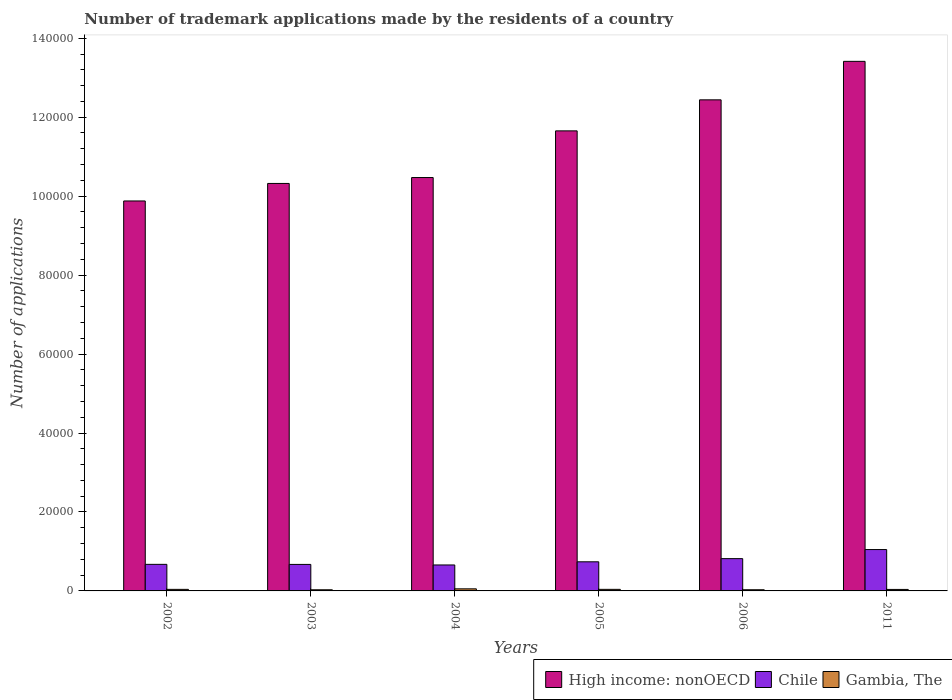How many different coloured bars are there?
Provide a succinct answer. 3. How many groups of bars are there?
Your response must be concise. 6. How many bars are there on the 6th tick from the left?
Ensure brevity in your answer.  3. What is the label of the 4th group of bars from the left?
Ensure brevity in your answer.  2005. What is the number of trademark applications made by the residents in Chile in 2003?
Your response must be concise. 6716. Across all years, what is the maximum number of trademark applications made by the residents in Chile?
Provide a short and direct response. 1.05e+04. Across all years, what is the minimum number of trademark applications made by the residents in Chile?
Your answer should be very brief. 6576. In which year was the number of trademark applications made by the residents in High income: nonOECD maximum?
Give a very brief answer. 2011. In which year was the number of trademark applications made by the residents in High income: nonOECD minimum?
Your answer should be very brief. 2002. What is the total number of trademark applications made by the residents in Chile in the graph?
Offer a terse response. 4.61e+04. What is the difference between the number of trademark applications made by the residents in Gambia, The in 2003 and that in 2004?
Ensure brevity in your answer.  -239. What is the difference between the number of trademark applications made by the residents in Gambia, The in 2011 and the number of trademark applications made by the residents in Chile in 2002?
Give a very brief answer. -6353. What is the average number of trademark applications made by the residents in Gambia, The per year?
Offer a terse response. 381.5. In the year 2011, what is the difference between the number of trademark applications made by the residents in Gambia, The and number of trademark applications made by the residents in Chile?
Give a very brief answer. -1.01e+04. What is the ratio of the number of trademark applications made by the residents in High income: nonOECD in 2002 to that in 2003?
Give a very brief answer. 0.96. What is the difference between the highest and the second highest number of trademark applications made by the residents in Chile?
Make the answer very short. 2302. What is the difference between the highest and the lowest number of trademark applications made by the residents in High income: nonOECD?
Offer a terse response. 3.54e+04. What does the 3rd bar from the left in 2006 represents?
Provide a succinct answer. Gambia, The. Is it the case that in every year, the sum of the number of trademark applications made by the residents in Gambia, The and number of trademark applications made by the residents in Chile is greater than the number of trademark applications made by the residents in High income: nonOECD?
Your response must be concise. No. Are all the bars in the graph horizontal?
Offer a very short reply. No. Are the values on the major ticks of Y-axis written in scientific E-notation?
Give a very brief answer. No. Does the graph contain any zero values?
Offer a terse response. No. Where does the legend appear in the graph?
Your response must be concise. Bottom right. How many legend labels are there?
Offer a terse response. 3. How are the legend labels stacked?
Give a very brief answer. Horizontal. What is the title of the graph?
Offer a very short reply. Number of trademark applications made by the residents of a country. What is the label or title of the X-axis?
Your response must be concise. Years. What is the label or title of the Y-axis?
Make the answer very short. Number of applications. What is the Number of applications of High income: nonOECD in 2002?
Your answer should be compact. 9.88e+04. What is the Number of applications of Chile in 2002?
Provide a short and direct response. 6730. What is the Number of applications of Gambia, The in 2002?
Ensure brevity in your answer.  395. What is the Number of applications of High income: nonOECD in 2003?
Your response must be concise. 1.03e+05. What is the Number of applications of Chile in 2003?
Keep it short and to the point. 6716. What is the Number of applications of Gambia, The in 2003?
Ensure brevity in your answer.  291. What is the Number of applications of High income: nonOECD in 2004?
Provide a succinct answer. 1.05e+05. What is the Number of applications in Chile in 2004?
Provide a short and direct response. 6576. What is the Number of applications in Gambia, The in 2004?
Offer a terse response. 530. What is the Number of applications in High income: nonOECD in 2005?
Your response must be concise. 1.17e+05. What is the Number of applications in Chile in 2005?
Provide a succinct answer. 7374. What is the Number of applications in Gambia, The in 2005?
Your response must be concise. 399. What is the Number of applications of High income: nonOECD in 2006?
Provide a succinct answer. 1.24e+05. What is the Number of applications of Chile in 2006?
Your answer should be compact. 8177. What is the Number of applications in Gambia, The in 2006?
Offer a very short reply. 297. What is the Number of applications in High income: nonOECD in 2011?
Give a very brief answer. 1.34e+05. What is the Number of applications in Chile in 2011?
Keep it short and to the point. 1.05e+04. What is the Number of applications in Gambia, The in 2011?
Your answer should be compact. 377. Across all years, what is the maximum Number of applications of High income: nonOECD?
Offer a very short reply. 1.34e+05. Across all years, what is the maximum Number of applications in Chile?
Ensure brevity in your answer.  1.05e+04. Across all years, what is the maximum Number of applications of Gambia, The?
Make the answer very short. 530. Across all years, what is the minimum Number of applications in High income: nonOECD?
Provide a succinct answer. 9.88e+04. Across all years, what is the minimum Number of applications in Chile?
Your answer should be very brief. 6576. Across all years, what is the minimum Number of applications in Gambia, The?
Your response must be concise. 291. What is the total Number of applications in High income: nonOECD in the graph?
Offer a very short reply. 6.82e+05. What is the total Number of applications of Chile in the graph?
Your answer should be very brief. 4.61e+04. What is the total Number of applications of Gambia, The in the graph?
Make the answer very short. 2289. What is the difference between the Number of applications of High income: nonOECD in 2002 and that in 2003?
Offer a very short reply. -4438. What is the difference between the Number of applications in Chile in 2002 and that in 2003?
Make the answer very short. 14. What is the difference between the Number of applications in Gambia, The in 2002 and that in 2003?
Give a very brief answer. 104. What is the difference between the Number of applications in High income: nonOECD in 2002 and that in 2004?
Your answer should be very brief. -5933. What is the difference between the Number of applications in Chile in 2002 and that in 2004?
Provide a succinct answer. 154. What is the difference between the Number of applications of Gambia, The in 2002 and that in 2004?
Offer a terse response. -135. What is the difference between the Number of applications in High income: nonOECD in 2002 and that in 2005?
Give a very brief answer. -1.78e+04. What is the difference between the Number of applications in Chile in 2002 and that in 2005?
Offer a terse response. -644. What is the difference between the Number of applications in Gambia, The in 2002 and that in 2005?
Offer a terse response. -4. What is the difference between the Number of applications in High income: nonOECD in 2002 and that in 2006?
Your answer should be very brief. -2.56e+04. What is the difference between the Number of applications in Chile in 2002 and that in 2006?
Make the answer very short. -1447. What is the difference between the Number of applications in High income: nonOECD in 2002 and that in 2011?
Your answer should be very brief. -3.54e+04. What is the difference between the Number of applications of Chile in 2002 and that in 2011?
Make the answer very short. -3749. What is the difference between the Number of applications in Gambia, The in 2002 and that in 2011?
Your response must be concise. 18. What is the difference between the Number of applications of High income: nonOECD in 2003 and that in 2004?
Make the answer very short. -1495. What is the difference between the Number of applications in Chile in 2003 and that in 2004?
Offer a very short reply. 140. What is the difference between the Number of applications of Gambia, The in 2003 and that in 2004?
Your answer should be very brief. -239. What is the difference between the Number of applications of High income: nonOECD in 2003 and that in 2005?
Your answer should be very brief. -1.33e+04. What is the difference between the Number of applications of Chile in 2003 and that in 2005?
Provide a succinct answer. -658. What is the difference between the Number of applications of Gambia, The in 2003 and that in 2005?
Offer a terse response. -108. What is the difference between the Number of applications of High income: nonOECD in 2003 and that in 2006?
Give a very brief answer. -2.12e+04. What is the difference between the Number of applications in Chile in 2003 and that in 2006?
Offer a very short reply. -1461. What is the difference between the Number of applications in Gambia, The in 2003 and that in 2006?
Keep it short and to the point. -6. What is the difference between the Number of applications in High income: nonOECD in 2003 and that in 2011?
Keep it short and to the point. -3.09e+04. What is the difference between the Number of applications in Chile in 2003 and that in 2011?
Offer a terse response. -3763. What is the difference between the Number of applications in Gambia, The in 2003 and that in 2011?
Provide a short and direct response. -86. What is the difference between the Number of applications of High income: nonOECD in 2004 and that in 2005?
Keep it short and to the point. -1.18e+04. What is the difference between the Number of applications of Chile in 2004 and that in 2005?
Provide a succinct answer. -798. What is the difference between the Number of applications of Gambia, The in 2004 and that in 2005?
Your answer should be compact. 131. What is the difference between the Number of applications in High income: nonOECD in 2004 and that in 2006?
Make the answer very short. -1.97e+04. What is the difference between the Number of applications in Chile in 2004 and that in 2006?
Your answer should be compact. -1601. What is the difference between the Number of applications of Gambia, The in 2004 and that in 2006?
Offer a terse response. 233. What is the difference between the Number of applications in High income: nonOECD in 2004 and that in 2011?
Keep it short and to the point. -2.94e+04. What is the difference between the Number of applications in Chile in 2004 and that in 2011?
Offer a terse response. -3903. What is the difference between the Number of applications of Gambia, The in 2004 and that in 2011?
Make the answer very short. 153. What is the difference between the Number of applications of High income: nonOECD in 2005 and that in 2006?
Your answer should be compact. -7862. What is the difference between the Number of applications in Chile in 2005 and that in 2006?
Offer a terse response. -803. What is the difference between the Number of applications of Gambia, The in 2005 and that in 2006?
Make the answer very short. 102. What is the difference between the Number of applications of High income: nonOECD in 2005 and that in 2011?
Offer a terse response. -1.76e+04. What is the difference between the Number of applications in Chile in 2005 and that in 2011?
Provide a short and direct response. -3105. What is the difference between the Number of applications of Gambia, The in 2005 and that in 2011?
Ensure brevity in your answer.  22. What is the difference between the Number of applications of High income: nonOECD in 2006 and that in 2011?
Give a very brief answer. -9748. What is the difference between the Number of applications of Chile in 2006 and that in 2011?
Give a very brief answer. -2302. What is the difference between the Number of applications of Gambia, The in 2006 and that in 2011?
Make the answer very short. -80. What is the difference between the Number of applications of High income: nonOECD in 2002 and the Number of applications of Chile in 2003?
Offer a very short reply. 9.21e+04. What is the difference between the Number of applications of High income: nonOECD in 2002 and the Number of applications of Gambia, The in 2003?
Keep it short and to the point. 9.85e+04. What is the difference between the Number of applications of Chile in 2002 and the Number of applications of Gambia, The in 2003?
Provide a short and direct response. 6439. What is the difference between the Number of applications of High income: nonOECD in 2002 and the Number of applications of Chile in 2004?
Ensure brevity in your answer.  9.22e+04. What is the difference between the Number of applications of High income: nonOECD in 2002 and the Number of applications of Gambia, The in 2004?
Offer a very short reply. 9.82e+04. What is the difference between the Number of applications in Chile in 2002 and the Number of applications in Gambia, The in 2004?
Keep it short and to the point. 6200. What is the difference between the Number of applications in High income: nonOECD in 2002 and the Number of applications in Chile in 2005?
Give a very brief answer. 9.14e+04. What is the difference between the Number of applications of High income: nonOECD in 2002 and the Number of applications of Gambia, The in 2005?
Provide a succinct answer. 9.84e+04. What is the difference between the Number of applications in Chile in 2002 and the Number of applications in Gambia, The in 2005?
Offer a very short reply. 6331. What is the difference between the Number of applications of High income: nonOECD in 2002 and the Number of applications of Chile in 2006?
Provide a short and direct response. 9.06e+04. What is the difference between the Number of applications of High income: nonOECD in 2002 and the Number of applications of Gambia, The in 2006?
Your answer should be very brief. 9.85e+04. What is the difference between the Number of applications in Chile in 2002 and the Number of applications in Gambia, The in 2006?
Offer a very short reply. 6433. What is the difference between the Number of applications in High income: nonOECD in 2002 and the Number of applications in Chile in 2011?
Ensure brevity in your answer.  8.83e+04. What is the difference between the Number of applications in High income: nonOECD in 2002 and the Number of applications in Gambia, The in 2011?
Your response must be concise. 9.84e+04. What is the difference between the Number of applications in Chile in 2002 and the Number of applications in Gambia, The in 2011?
Ensure brevity in your answer.  6353. What is the difference between the Number of applications of High income: nonOECD in 2003 and the Number of applications of Chile in 2004?
Offer a very short reply. 9.66e+04. What is the difference between the Number of applications in High income: nonOECD in 2003 and the Number of applications in Gambia, The in 2004?
Offer a terse response. 1.03e+05. What is the difference between the Number of applications in Chile in 2003 and the Number of applications in Gambia, The in 2004?
Offer a very short reply. 6186. What is the difference between the Number of applications of High income: nonOECD in 2003 and the Number of applications of Chile in 2005?
Your answer should be compact. 9.58e+04. What is the difference between the Number of applications of High income: nonOECD in 2003 and the Number of applications of Gambia, The in 2005?
Offer a terse response. 1.03e+05. What is the difference between the Number of applications of Chile in 2003 and the Number of applications of Gambia, The in 2005?
Offer a terse response. 6317. What is the difference between the Number of applications of High income: nonOECD in 2003 and the Number of applications of Chile in 2006?
Make the answer very short. 9.50e+04. What is the difference between the Number of applications in High income: nonOECD in 2003 and the Number of applications in Gambia, The in 2006?
Give a very brief answer. 1.03e+05. What is the difference between the Number of applications in Chile in 2003 and the Number of applications in Gambia, The in 2006?
Your response must be concise. 6419. What is the difference between the Number of applications of High income: nonOECD in 2003 and the Number of applications of Chile in 2011?
Ensure brevity in your answer.  9.27e+04. What is the difference between the Number of applications in High income: nonOECD in 2003 and the Number of applications in Gambia, The in 2011?
Your answer should be very brief. 1.03e+05. What is the difference between the Number of applications of Chile in 2003 and the Number of applications of Gambia, The in 2011?
Ensure brevity in your answer.  6339. What is the difference between the Number of applications in High income: nonOECD in 2004 and the Number of applications in Chile in 2005?
Make the answer very short. 9.73e+04. What is the difference between the Number of applications in High income: nonOECD in 2004 and the Number of applications in Gambia, The in 2005?
Offer a terse response. 1.04e+05. What is the difference between the Number of applications in Chile in 2004 and the Number of applications in Gambia, The in 2005?
Your answer should be very brief. 6177. What is the difference between the Number of applications in High income: nonOECD in 2004 and the Number of applications in Chile in 2006?
Your answer should be very brief. 9.65e+04. What is the difference between the Number of applications of High income: nonOECD in 2004 and the Number of applications of Gambia, The in 2006?
Ensure brevity in your answer.  1.04e+05. What is the difference between the Number of applications of Chile in 2004 and the Number of applications of Gambia, The in 2006?
Keep it short and to the point. 6279. What is the difference between the Number of applications in High income: nonOECD in 2004 and the Number of applications in Chile in 2011?
Your answer should be compact. 9.42e+04. What is the difference between the Number of applications of High income: nonOECD in 2004 and the Number of applications of Gambia, The in 2011?
Provide a succinct answer. 1.04e+05. What is the difference between the Number of applications of Chile in 2004 and the Number of applications of Gambia, The in 2011?
Keep it short and to the point. 6199. What is the difference between the Number of applications of High income: nonOECD in 2005 and the Number of applications of Chile in 2006?
Keep it short and to the point. 1.08e+05. What is the difference between the Number of applications of High income: nonOECD in 2005 and the Number of applications of Gambia, The in 2006?
Your answer should be compact. 1.16e+05. What is the difference between the Number of applications of Chile in 2005 and the Number of applications of Gambia, The in 2006?
Give a very brief answer. 7077. What is the difference between the Number of applications of High income: nonOECD in 2005 and the Number of applications of Chile in 2011?
Give a very brief answer. 1.06e+05. What is the difference between the Number of applications of High income: nonOECD in 2005 and the Number of applications of Gambia, The in 2011?
Keep it short and to the point. 1.16e+05. What is the difference between the Number of applications in Chile in 2005 and the Number of applications in Gambia, The in 2011?
Provide a succinct answer. 6997. What is the difference between the Number of applications of High income: nonOECD in 2006 and the Number of applications of Chile in 2011?
Your answer should be compact. 1.14e+05. What is the difference between the Number of applications of High income: nonOECD in 2006 and the Number of applications of Gambia, The in 2011?
Your answer should be compact. 1.24e+05. What is the difference between the Number of applications in Chile in 2006 and the Number of applications in Gambia, The in 2011?
Provide a succinct answer. 7800. What is the average Number of applications in High income: nonOECD per year?
Your answer should be compact. 1.14e+05. What is the average Number of applications of Chile per year?
Offer a very short reply. 7675.33. What is the average Number of applications in Gambia, The per year?
Provide a short and direct response. 381.5. In the year 2002, what is the difference between the Number of applications of High income: nonOECD and Number of applications of Chile?
Give a very brief answer. 9.20e+04. In the year 2002, what is the difference between the Number of applications in High income: nonOECD and Number of applications in Gambia, The?
Keep it short and to the point. 9.84e+04. In the year 2002, what is the difference between the Number of applications of Chile and Number of applications of Gambia, The?
Ensure brevity in your answer.  6335. In the year 2003, what is the difference between the Number of applications in High income: nonOECD and Number of applications in Chile?
Make the answer very short. 9.65e+04. In the year 2003, what is the difference between the Number of applications in High income: nonOECD and Number of applications in Gambia, The?
Make the answer very short. 1.03e+05. In the year 2003, what is the difference between the Number of applications in Chile and Number of applications in Gambia, The?
Keep it short and to the point. 6425. In the year 2004, what is the difference between the Number of applications in High income: nonOECD and Number of applications in Chile?
Ensure brevity in your answer.  9.81e+04. In the year 2004, what is the difference between the Number of applications in High income: nonOECD and Number of applications in Gambia, The?
Your response must be concise. 1.04e+05. In the year 2004, what is the difference between the Number of applications of Chile and Number of applications of Gambia, The?
Keep it short and to the point. 6046. In the year 2005, what is the difference between the Number of applications in High income: nonOECD and Number of applications in Chile?
Provide a short and direct response. 1.09e+05. In the year 2005, what is the difference between the Number of applications of High income: nonOECD and Number of applications of Gambia, The?
Your response must be concise. 1.16e+05. In the year 2005, what is the difference between the Number of applications of Chile and Number of applications of Gambia, The?
Keep it short and to the point. 6975. In the year 2006, what is the difference between the Number of applications in High income: nonOECD and Number of applications in Chile?
Your answer should be very brief. 1.16e+05. In the year 2006, what is the difference between the Number of applications in High income: nonOECD and Number of applications in Gambia, The?
Provide a succinct answer. 1.24e+05. In the year 2006, what is the difference between the Number of applications of Chile and Number of applications of Gambia, The?
Keep it short and to the point. 7880. In the year 2011, what is the difference between the Number of applications of High income: nonOECD and Number of applications of Chile?
Your answer should be very brief. 1.24e+05. In the year 2011, what is the difference between the Number of applications in High income: nonOECD and Number of applications in Gambia, The?
Your answer should be very brief. 1.34e+05. In the year 2011, what is the difference between the Number of applications in Chile and Number of applications in Gambia, The?
Ensure brevity in your answer.  1.01e+04. What is the ratio of the Number of applications of Chile in 2002 to that in 2003?
Give a very brief answer. 1. What is the ratio of the Number of applications in Gambia, The in 2002 to that in 2003?
Keep it short and to the point. 1.36. What is the ratio of the Number of applications of High income: nonOECD in 2002 to that in 2004?
Ensure brevity in your answer.  0.94. What is the ratio of the Number of applications of Chile in 2002 to that in 2004?
Give a very brief answer. 1.02. What is the ratio of the Number of applications in Gambia, The in 2002 to that in 2004?
Give a very brief answer. 0.75. What is the ratio of the Number of applications in High income: nonOECD in 2002 to that in 2005?
Give a very brief answer. 0.85. What is the ratio of the Number of applications in Chile in 2002 to that in 2005?
Provide a succinct answer. 0.91. What is the ratio of the Number of applications of Gambia, The in 2002 to that in 2005?
Make the answer very short. 0.99. What is the ratio of the Number of applications of High income: nonOECD in 2002 to that in 2006?
Make the answer very short. 0.79. What is the ratio of the Number of applications of Chile in 2002 to that in 2006?
Provide a succinct answer. 0.82. What is the ratio of the Number of applications of Gambia, The in 2002 to that in 2006?
Your response must be concise. 1.33. What is the ratio of the Number of applications of High income: nonOECD in 2002 to that in 2011?
Offer a very short reply. 0.74. What is the ratio of the Number of applications of Chile in 2002 to that in 2011?
Make the answer very short. 0.64. What is the ratio of the Number of applications of Gambia, The in 2002 to that in 2011?
Make the answer very short. 1.05. What is the ratio of the Number of applications of High income: nonOECD in 2003 to that in 2004?
Your response must be concise. 0.99. What is the ratio of the Number of applications in Chile in 2003 to that in 2004?
Ensure brevity in your answer.  1.02. What is the ratio of the Number of applications in Gambia, The in 2003 to that in 2004?
Your answer should be very brief. 0.55. What is the ratio of the Number of applications in High income: nonOECD in 2003 to that in 2005?
Your answer should be very brief. 0.89. What is the ratio of the Number of applications of Chile in 2003 to that in 2005?
Offer a very short reply. 0.91. What is the ratio of the Number of applications of Gambia, The in 2003 to that in 2005?
Provide a short and direct response. 0.73. What is the ratio of the Number of applications in High income: nonOECD in 2003 to that in 2006?
Ensure brevity in your answer.  0.83. What is the ratio of the Number of applications of Chile in 2003 to that in 2006?
Offer a terse response. 0.82. What is the ratio of the Number of applications of Gambia, The in 2003 to that in 2006?
Provide a succinct answer. 0.98. What is the ratio of the Number of applications of High income: nonOECD in 2003 to that in 2011?
Your answer should be very brief. 0.77. What is the ratio of the Number of applications of Chile in 2003 to that in 2011?
Give a very brief answer. 0.64. What is the ratio of the Number of applications in Gambia, The in 2003 to that in 2011?
Keep it short and to the point. 0.77. What is the ratio of the Number of applications of High income: nonOECD in 2004 to that in 2005?
Make the answer very short. 0.9. What is the ratio of the Number of applications of Chile in 2004 to that in 2005?
Offer a terse response. 0.89. What is the ratio of the Number of applications in Gambia, The in 2004 to that in 2005?
Offer a terse response. 1.33. What is the ratio of the Number of applications in High income: nonOECD in 2004 to that in 2006?
Your response must be concise. 0.84. What is the ratio of the Number of applications in Chile in 2004 to that in 2006?
Your response must be concise. 0.8. What is the ratio of the Number of applications of Gambia, The in 2004 to that in 2006?
Keep it short and to the point. 1.78. What is the ratio of the Number of applications in High income: nonOECD in 2004 to that in 2011?
Your answer should be very brief. 0.78. What is the ratio of the Number of applications in Chile in 2004 to that in 2011?
Your answer should be very brief. 0.63. What is the ratio of the Number of applications of Gambia, The in 2004 to that in 2011?
Your answer should be very brief. 1.41. What is the ratio of the Number of applications in High income: nonOECD in 2005 to that in 2006?
Offer a terse response. 0.94. What is the ratio of the Number of applications in Chile in 2005 to that in 2006?
Provide a short and direct response. 0.9. What is the ratio of the Number of applications in Gambia, The in 2005 to that in 2006?
Your answer should be very brief. 1.34. What is the ratio of the Number of applications of High income: nonOECD in 2005 to that in 2011?
Your answer should be very brief. 0.87. What is the ratio of the Number of applications in Chile in 2005 to that in 2011?
Your response must be concise. 0.7. What is the ratio of the Number of applications in Gambia, The in 2005 to that in 2011?
Give a very brief answer. 1.06. What is the ratio of the Number of applications of High income: nonOECD in 2006 to that in 2011?
Make the answer very short. 0.93. What is the ratio of the Number of applications in Chile in 2006 to that in 2011?
Your response must be concise. 0.78. What is the ratio of the Number of applications in Gambia, The in 2006 to that in 2011?
Make the answer very short. 0.79. What is the difference between the highest and the second highest Number of applications of High income: nonOECD?
Your response must be concise. 9748. What is the difference between the highest and the second highest Number of applications in Chile?
Your answer should be very brief. 2302. What is the difference between the highest and the second highest Number of applications in Gambia, The?
Ensure brevity in your answer.  131. What is the difference between the highest and the lowest Number of applications in High income: nonOECD?
Provide a short and direct response. 3.54e+04. What is the difference between the highest and the lowest Number of applications in Chile?
Keep it short and to the point. 3903. What is the difference between the highest and the lowest Number of applications of Gambia, The?
Make the answer very short. 239. 